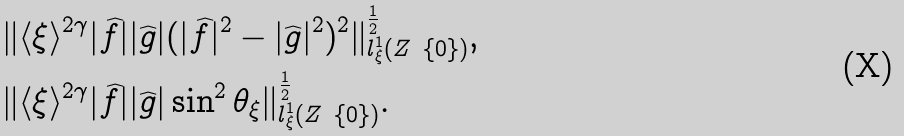Convert formula to latex. <formula><loc_0><loc_0><loc_500><loc_500>& \| \langle \xi \rangle ^ { 2 \gamma } | \widehat { f } | | \widehat { g } | ( | \widehat { f } | ^ { 2 } - | \widehat { g } | ^ { 2 } ) ^ { 2 } \| ^ { \frac { 1 } { 2 } } _ { l ^ { 1 } _ { \xi } ( Z \ \{ 0 \} ) } , \\ & \| \langle \xi \rangle ^ { 2 \gamma } | \widehat { f } | | \widehat { g } | \sin ^ { 2 } \theta _ { \xi } \| ^ { \frac { 1 } { 2 } } _ { l ^ { 1 } _ { \xi } ( Z \ \{ 0 \} ) } .</formula> 